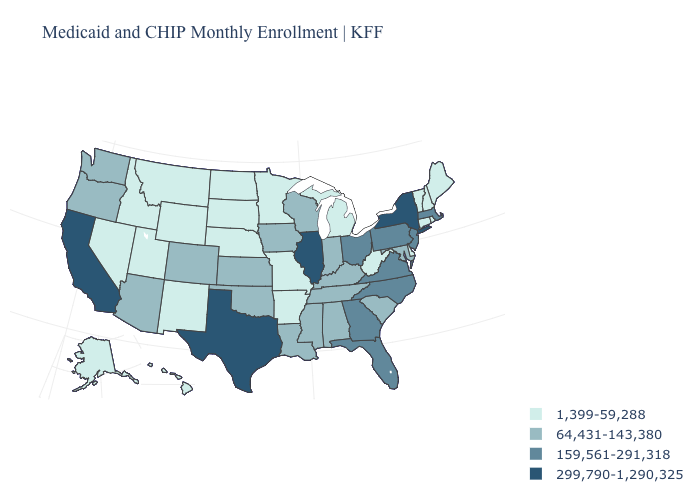What is the highest value in the USA?
Be succinct. 299,790-1,290,325. What is the value of California?
Quick response, please. 299,790-1,290,325. Name the states that have a value in the range 159,561-291,318?
Write a very short answer. Florida, Georgia, Massachusetts, New Jersey, North Carolina, Ohio, Pennsylvania, Virginia. What is the lowest value in the MidWest?
Write a very short answer. 1,399-59,288. Among the states that border Montana , which have the highest value?
Be succinct. Idaho, North Dakota, South Dakota, Wyoming. Does West Virginia have a lower value than Alaska?
Write a very short answer. No. Name the states that have a value in the range 64,431-143,380?
Be succinct. Alabama, Arizona, Colorado, Indiana, Iowa, Kansas, Kentucky, Louisiana, Maryland, Mississippi, Oklahoma, Oregon, South Carolina, Tennessee, Washington, Wisconsin. What is the lowest value in the South?
Keep it brief. 1,399-59,288. What is the value of Ohio?
Be succinct. 159,561-291,318. Does North Carolina have the same value as Massachusetts?
Concise answer only. Yes. Among the states that border New Jersey , does Delaware have the lowest value?
Answer briefly. Yes. Does Illinois have the highest value in the USA?
Concise answer only. Yes. Does Massachusetts have the highest value in the Northeast?
Write a very short answer. No. Is the legend a continuous bar?
Answer briefly. No. What is the value of Vermont?
Answer briefly. 1,399-59,288. 